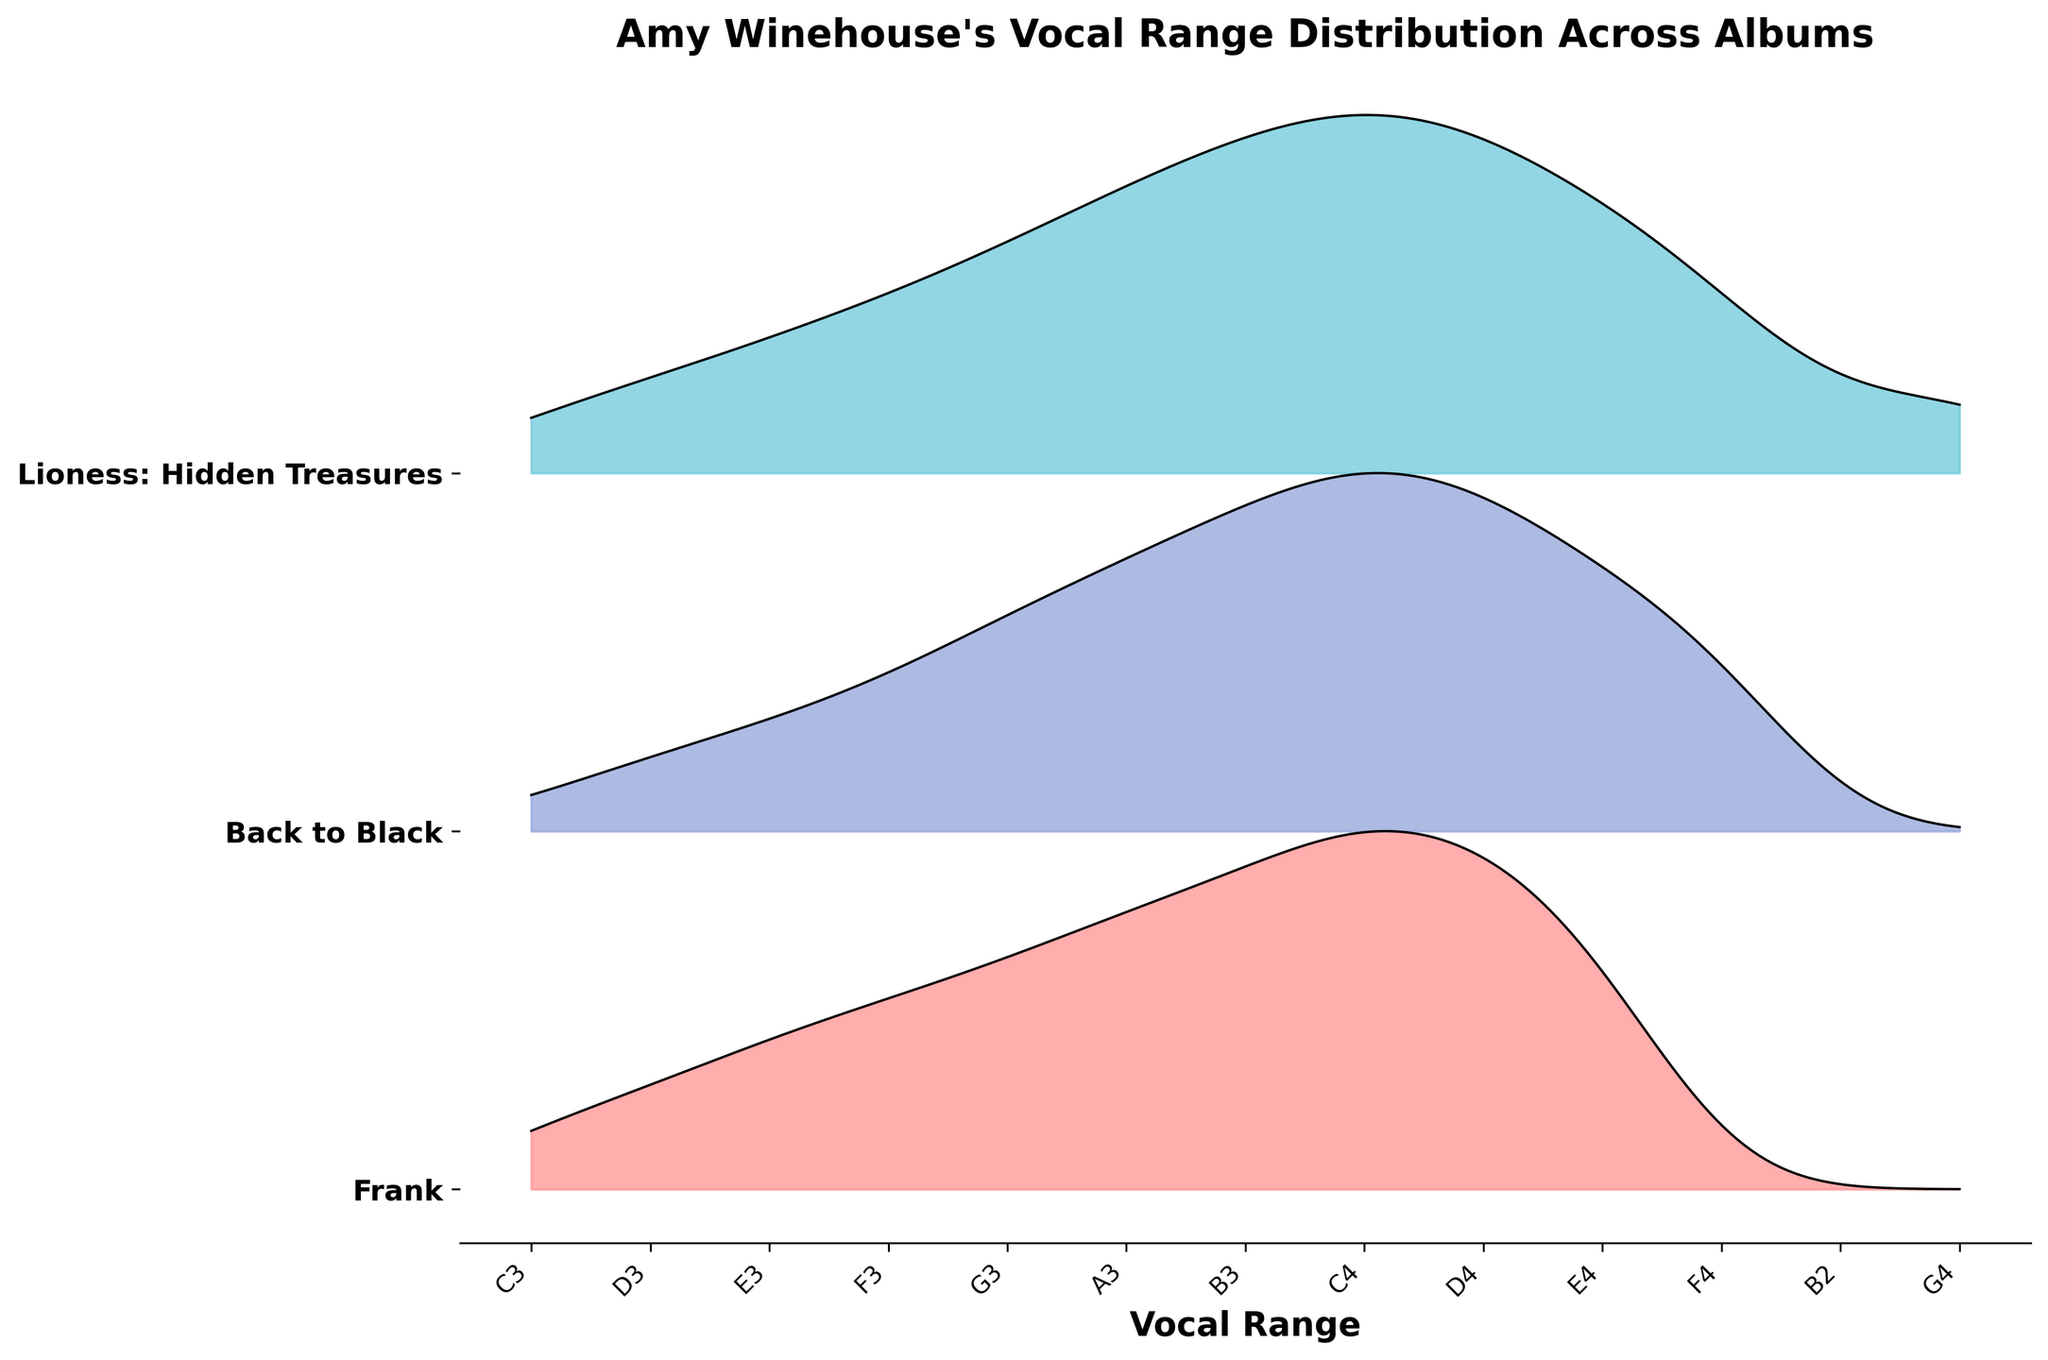What is the title of the plot? The title of the plot is displayed prominently at the top and reads, "Amy Winehouse's Vocal Range Distribution Across Albums"
Answer: "Amy Winehouse's Vocal Range Distribution Across Albums" Which album shows the widest vocal range distribution? To determine the widest vocal range distribution, observe which album covers the most notes in the figure. "Lioness: Hidden Treasures" stretches across a broad range of notes from B2 to G4, indicating it has the widest distribution.
Answer: "Lioness: Hidden Treasures" Which note has the highest frequency in the album "Back to Black"? Locate the segment in the plot corresponding to "Back to Black," then identify the peak point within that segment. The highest peak is at C4.
Answer: "C4" Compare the frequency distribution between "Frank" and "Back to Black" at note C3. Which album has a higher frequency? Identify the height of the ridgeline for note C3 in both "Frank" and "Back to Black." In "Frank," the frequency for C3 is higher compared to that in "Back to Black."
Answer: "Frank" What is the most frequent note in the album "Lioness: Hidden Treasures"? Examine the segment for "Lioness: Hidden Treasures" and identify the peak note. The highest peak in this segment is at C4.
Answer: "C4" How many albums are displayed in the figure? Count the unique number of segments in the plot representing different albums. There are three segments: "Frank," "Back to Black," and "Lioness: Hidden Treasures."
Answer: "Three" Is the note E4 more frequent in "Frank" or "Lioness: Hidden Treasures"? Compare the heights of the ridgelines at note E4 for both "Frank" and "Lioness: Hidden Treasures." The height is greater in "Lioness: Hidden Treasures."
Answer: "Lioness: Hidden Treasures" Which album shows the most consistent high frequency across its notes? Look for the album where ridgelines show relatively high and consistent frequency peaks. "Lioness: Hidden Treasures" displays consistently high frequency across a broad range of notes.
Answer: "Lioness: Hidden Treasures" What pattern can be observed in the frequency of higher notes (above C4) in "Back to Black" compared to "Frank"? Analyze the segments for "Back to Black" and "Frank." Higher notes (above C4) in "Back to Black" show increasing trends in frequency, whereas in "Frank," the frequency declines.
Answer: "Increasing in Back to Black, Decreasing in Frank" 